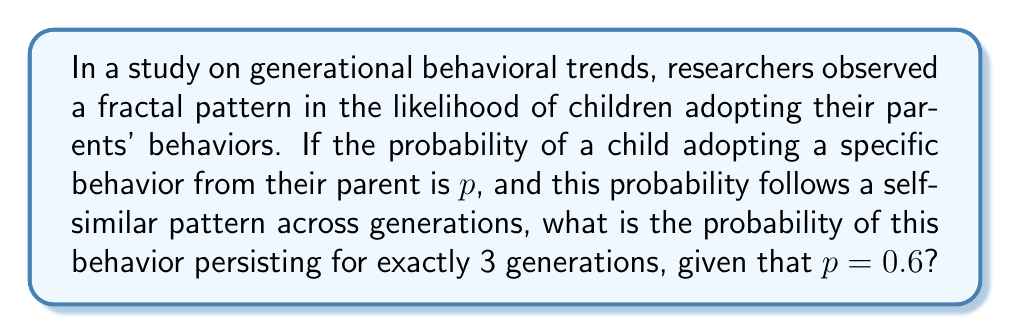Help me with this question. To solve this problem, we need to understand the fractal nature of behavioral transmission across generations and apply probability rules. Let's break it down step-by-step:

1. The probability of a behavior persisting for exactly 3 generations means:
   - It must be adopted by the 1st and 2nd generations
   - It must not be adopted by the 3rd generation

2. Probability of adoption for each generation:
   - 1st generation to 2nd generation: $p = 0.6$
   - 2nd generation to 3rd generation: $p = 0.6$

3. Probability of non-adoption (for the 3rd generation):
   - $1 - p = 1 - 0.6 = 0.4$

4. To calculate the probability of the behavior persisting for exactly 3 generations, we multiply:
   $$P(\text{3 generations}) = p \times p \times (1-p)$$

5. Substituting the values:
   $$P(\text{3 generations}) = 0.6 \times 0.6 \times 0.4$$

6. Calculating:
   $$P(\text{3 generations}) = 0.36 \times 0.4 = 0.144$$

Therefore, the probability of the behavior persisting for exactly 3 generations is 0.144 or 14.4%.
Answer: 0.144 